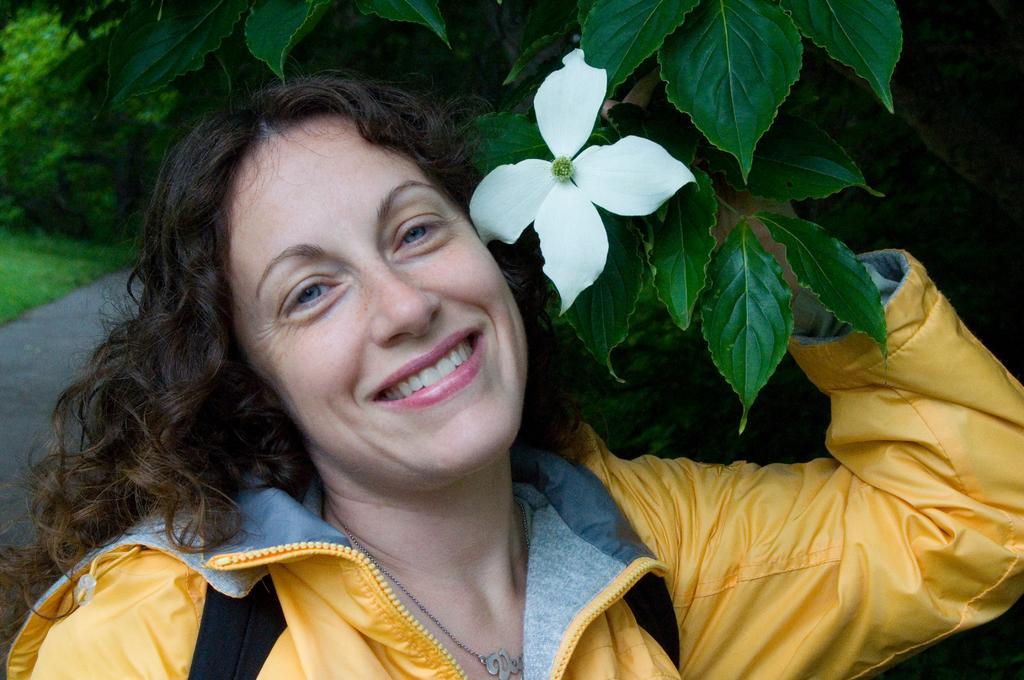Could you give a brief overview of what you see in this image? In this picture I can see a woman standing and holding a tree branch and I can see a flower and few leaves and I can see another tree in the back and grass on the ground. 